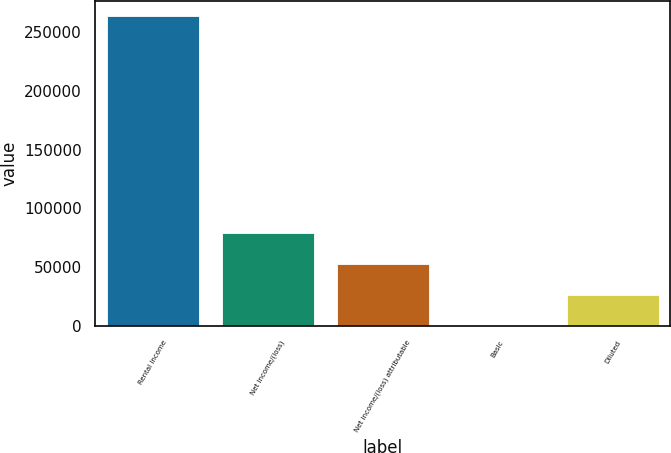<chart> <loc_0><loc_0><loc_500><loc_500><bar_chart><fcel>Rental income<fcel>Net income/(loss)<fcel>Net income/(loss) attributable<fcel>Basic<fcel>Diluted<nl><fcel>263256<fcel>78976.8<fcel>52651.2<fcel>0.07<fcel>26325.7<nl></chart> 